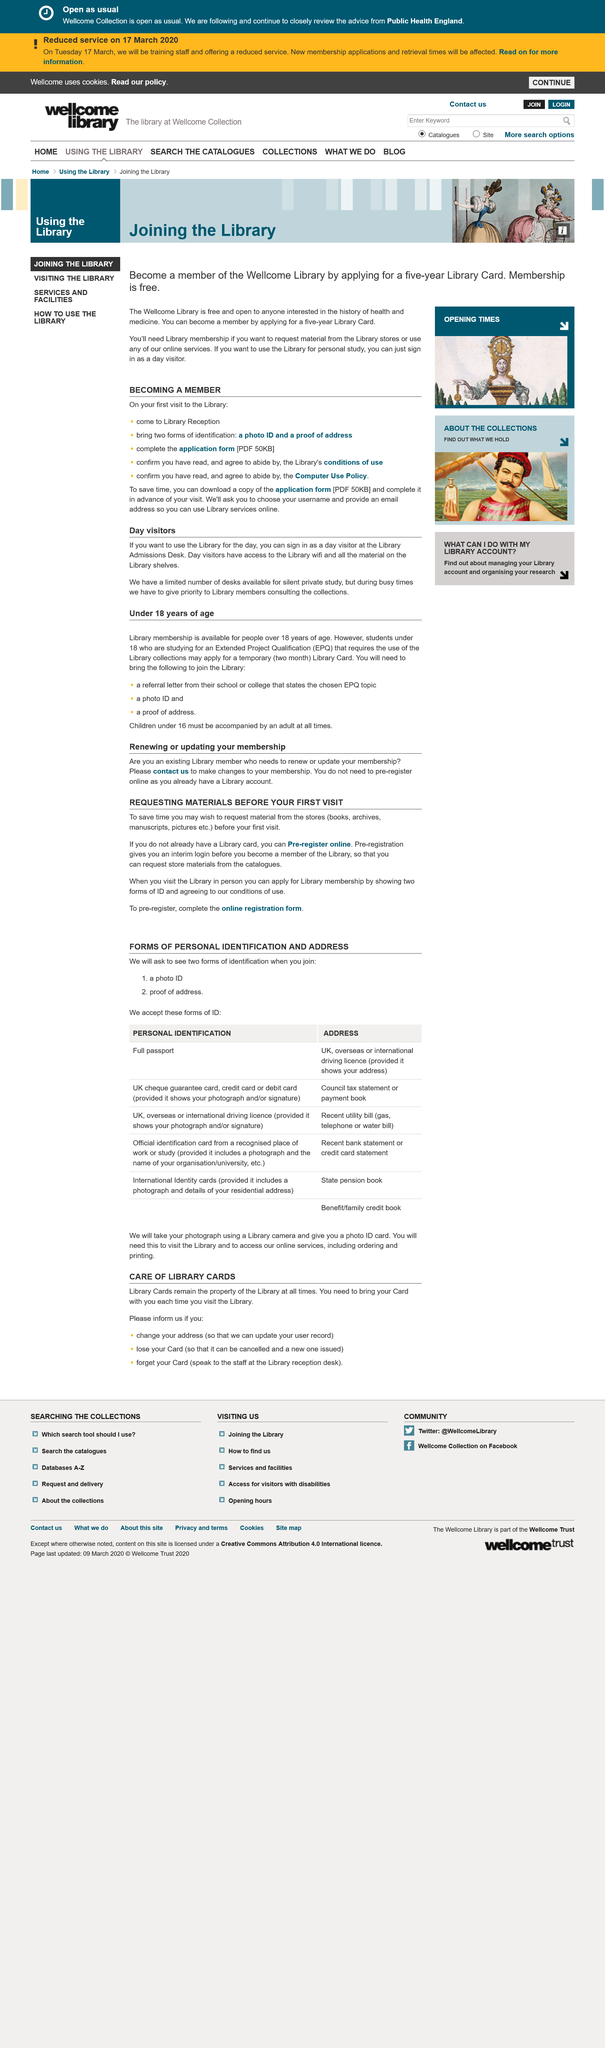Draw attention to some important aspects in this diagram. It is not necessary to pre-register if you already have a Library account. It is possible to save time before a visit to the Library by requesting material from the stores (books, archives, manuscripts, pictures, etc.) prior to arrival. To use the library for a day as a day visitor, please sign in at the Admissions Desk. To renew or update your library membership, existing members must contact the library to make changes to their membership. During periods of high demand, library members receive priority in accessing resources and services. 